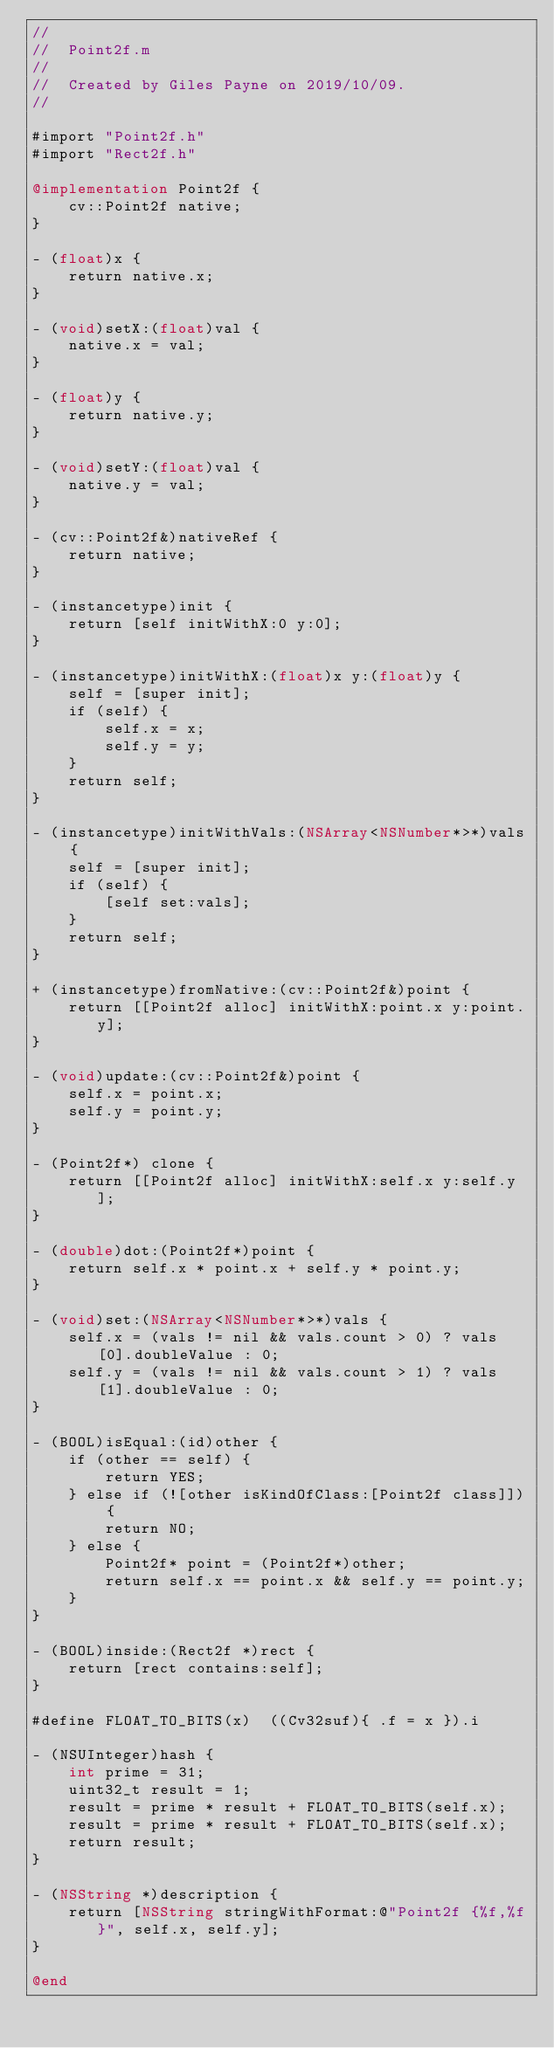Convert code to text. <code><loc_0><loc_0><loc_500><loc_500><_ObjectiveC_>//
//  Point2f.m
//
//  Created by Giles Payne on 2019/10/09.
//

#import "Point2f.h"
#import "Rect2f.h"

@implementation Point2f {
    cv::Point2f native;
}

- (float)x {
    return native.x;
}

- (void)setX:(float)val {
    native.x = val;
}

- (float)y {
    return native.y;
}

- (void)setY:(float)val {
    native.y = val;
}

- (cv::Point2f&)nativeRef {
    return native;
}

- (instancetype)init {
    return [self initWithX:0 y:0];
}

- (instancetype)initWithX:(float)x y:(float)y {
    self = [super init];
    if (self) {
        self.x = x;
        self.y = y;
    }
    return self;
}

- (instancetype)initWithVals:(NSArray<NSNumber*>*)vals {
    self = [super init];
    if (self) {
        [self set:vals];
    }
    return self;
}

+ (instancetype)fromNative:(cv::Point2f&)point {
    return [[Point2f alloc] initWithX:point.x y:point.y];
}

- (void)update:(cv::Point2f&)point {
    self.x = point.x;
    self.y = point.y;
}

- (Point2f*) clone {
    return [[Point2f alloc] initWithX:self.x y:self.y];
}

- (double)dot:(Point2f*)point {
    return self.x * point.x + self.y * point.y;
}

- (void)set:(NSArray<NSNumber*>*)vals {
    self.x = (vals != nil && vals.count > 0) ? vals[0].doubleValue : 0;
    self.y = (vals != nil && vals.count > 1) ? vals[1].doubleValue : 0;
}

- (BOOL)isEqual:(id)other {
    if (other == self) {
        return YES;
    } else if (![other isKindOfClass:[Point2f class]]) {
        return NO;
    } else {
        Point2f* point = (Point2f*)other;
        return self.x == point.x && self.y == point.y;
    }
}

- (BOOL)inside:(Rect2f *)rect {
    return [rect contains:self];
}

#define FLOAT_TO_BITS(x)  ((Cv32suf){ .f = x }).i

- (NSUInteger)hash {
    int prime = 31;
    uint32_t result = 1;
    result = prime * result + FLOAT_TO_BITS(self.x);
    result = prime * result + FLOAT_TO_BITS(self.x);
    return result;
}

- (NSString *)description {
    return [NSString stringWithFormat:@"Point2f {%f,%f}", self.x, self.y];
}

@end
</code> 